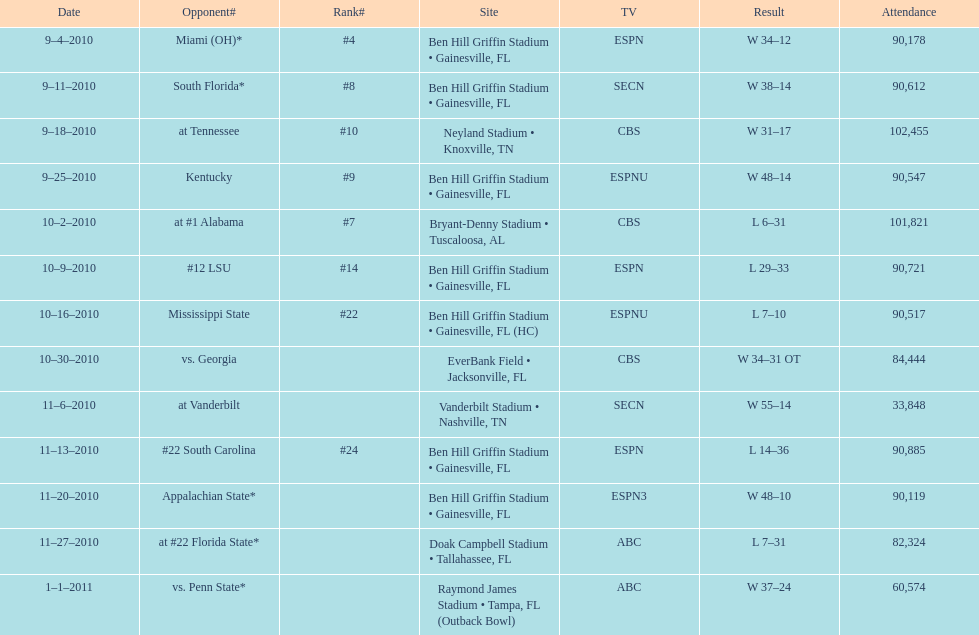How many matches occurred at ben hill griffin stadium throughout the 2010-2011 season? 7. 